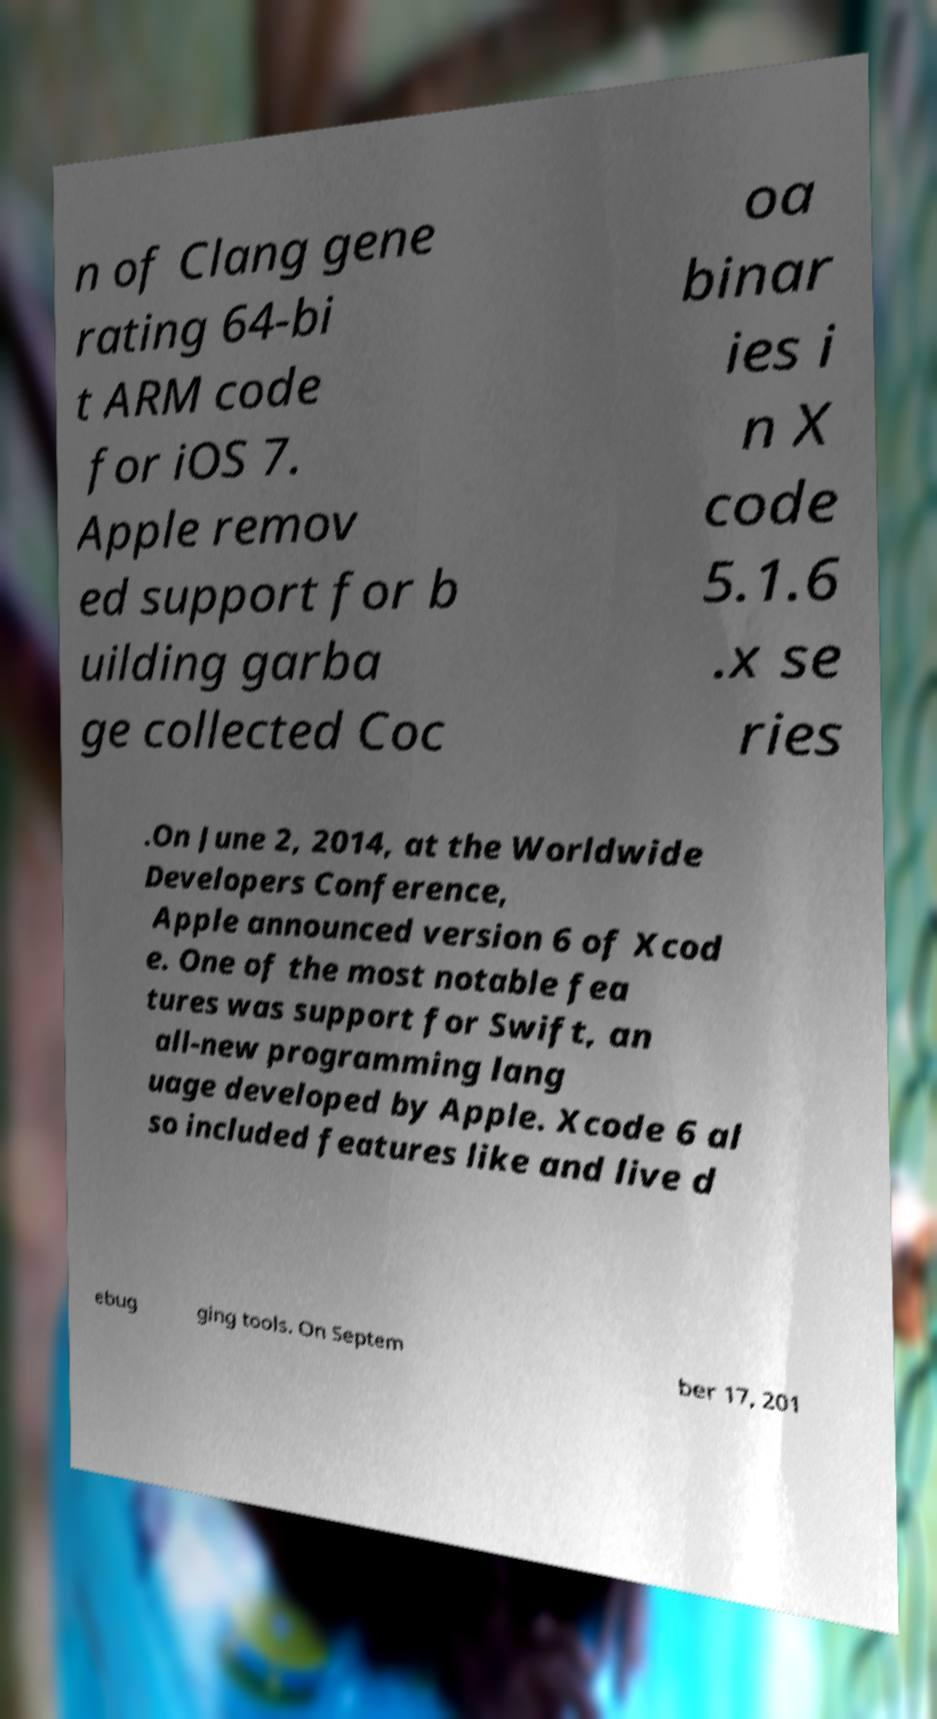I need the written content from this picture converted into text. Can you do that? n of Clang gene rating 64-bi t ARM code for iOS 7. Apple remov ed support for b uilding garba ge collected Coc oa binar ies i n X code 5.1.6 .x se ries .On June 2, 2014, at the Worldwide Developers Conference, Apple announced version 6 of Xcod e. One of the most notable fea tures was support for Swift, an all-new programming lang uage developed by Apple. Xcode 6 al so included features like and live d ebug ging tools. On Septem ber 17, 201 